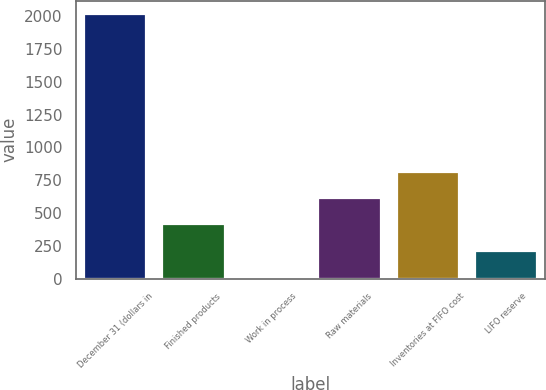Convert chart to OTSL. <chart><loc_0><loc_0><loc_500><loc_500><bar_chart><fcel>December 31 (dollars in<fcel>Finished products<fcel>Work in process<fcel>Raw materials<fcel>Inventories at FIFO cost<fcel>LIFO reserve<nl><fcel>2016<fcel>413.6<fcel>13<fcel>613.9<fcel>814.2<fcel>213.3<nl></chart> 